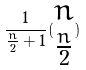<formula> <loc_0><loc_0><loc_500><loc_500>\frac { 1 } { \frac { n } { 2 } + 1 } ( \begin{matrix} n \\ \frac { n } { 2 } \end{matrix} )</formula> 